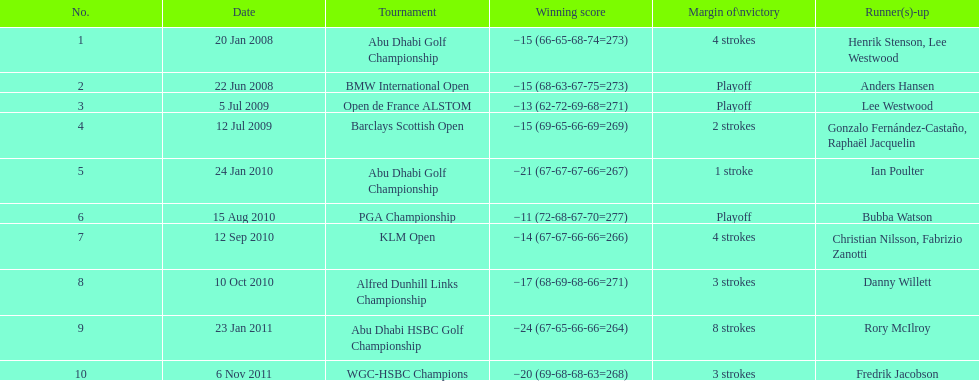Who had the top score in the pga championship? Bubba Watson. Give me the full table as a dictionary. {'header': ['No.', 'Date', 'Tournament', 'Winning score', 'Margin of\\nvictory', 'Runner(s)-up'], 'rows': [['1', '20 Jan 2008', 'Abu Dhabi Golf Championship', '−15 (66-65-68-74=273)', '4 strokes', 'Henrik Stenson, Lee Westwood'], ['2', '22 Jun 2008', 'BMW International Open', '−15 (68-63-67-75=273)', 'Playoff', 'Anders Hansen'], ['3', '5 Jul 2009', 'Open de France ALSTOM', '−13 (62-72-69-68=271)', 'Playoff', 'Lee Westwood'], ['4', '12 Jul 2009', 'Barclays Scottish Open', '−15 (69-65-66-69=269)', '2 strokes', 'Gonzalo Fernández-Castaño, Raphaël Jacquelin'], ['5', '24 Jan 2010', 'Abu Dhabi Golf Championship', '−21 (67-67-67-66=267)', '1 stroke', 'Ian Poulter'], ['6', '15 Aug 2010', 'PGA Championship', '−11 (72-68-67-70=277)', 'Playoff', 'Bubba Watson'], ['7', '12 Sep 2010', 'KLM Open', '−14 (67-67-66-66=266)', '4 strokes', 'Christian Nilsson, Fabrizio Zanotti'], ['8', '10 Oct 2010', 'Alfred Dunhill Links Championship', '−17 (68-69-68-66=271)', '3 strokes', 'Danny Willett'], ['9', '23 Jan 2011', 'Abu Dhabi HSBC Golf Championship', '−24 (67-65-66-66=264)', '8 strokes', 'Rory McIlroy'], ['10', '6 Nov 2011', 'WGC-HSBC Champions', '−20 (69-68-68-63=268)', '3 strokes', 'Fredrik Jacobson']]} 